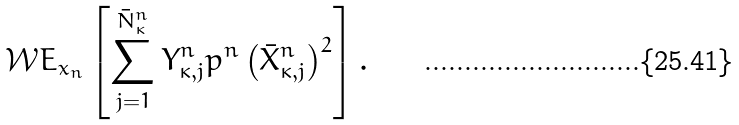<formula> <loc_0><loc_0><loc_500><loc_500>\mathcal { W } E _ { x _ { n } } \left [ \sum _ { j = 1 } ^ { \bar { N } _ { \kappa } ^ { n } } Y _ { \kappa , j } ^ { n } p ^ { n } \left ( \bar { X } _ { \kappa , j } ^ { n } \right ) ^ { 2 } \right ] .</formula> 